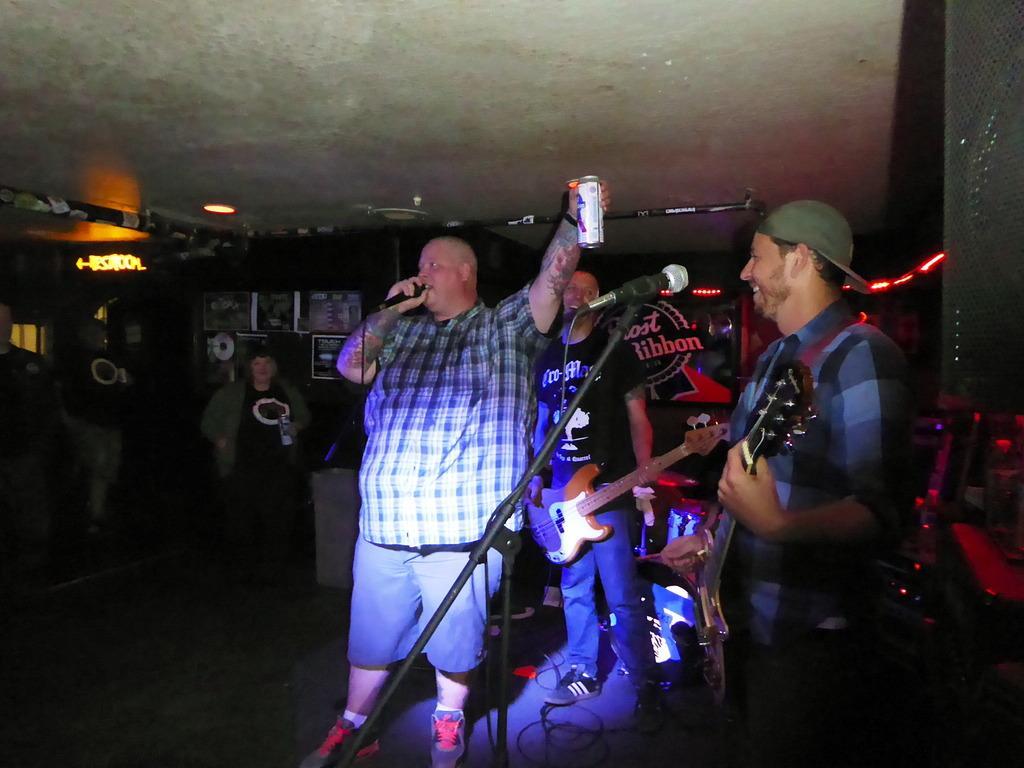Could you give a brief overview of what you see in this image? In this picture i could see three persons performing a musical show, in the right side a person holding a guitar in his hand and the middle person holding a tin in his hand and mic, and in the back ground there is a text written and lights all around. 